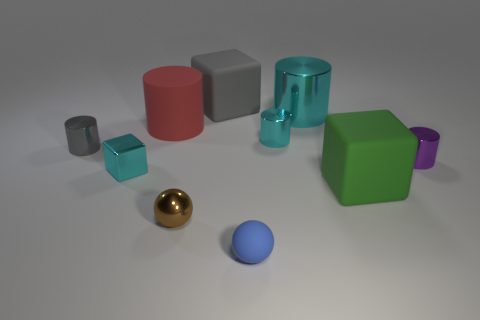Subtract all gray cylinders. How many cylinders are left? 4 Subtract all matte cylinders. How many cylinders are left? 4 Subtract all green cylinders. Subtract all green cubes. How many cylinders are left? 5 Subtract all blocks. How many objects are left? 7 Add 5 small cyan things. How many small cyan things exist? 7 Subtract 0 gray spheres. How many objects are left? 10 Subtract all tiny rubber balls. Subtract all tiny purple objects. How many objects are left? 8 Add 1 cyan shiny objects. How many cyan shiny objects are left? 4 